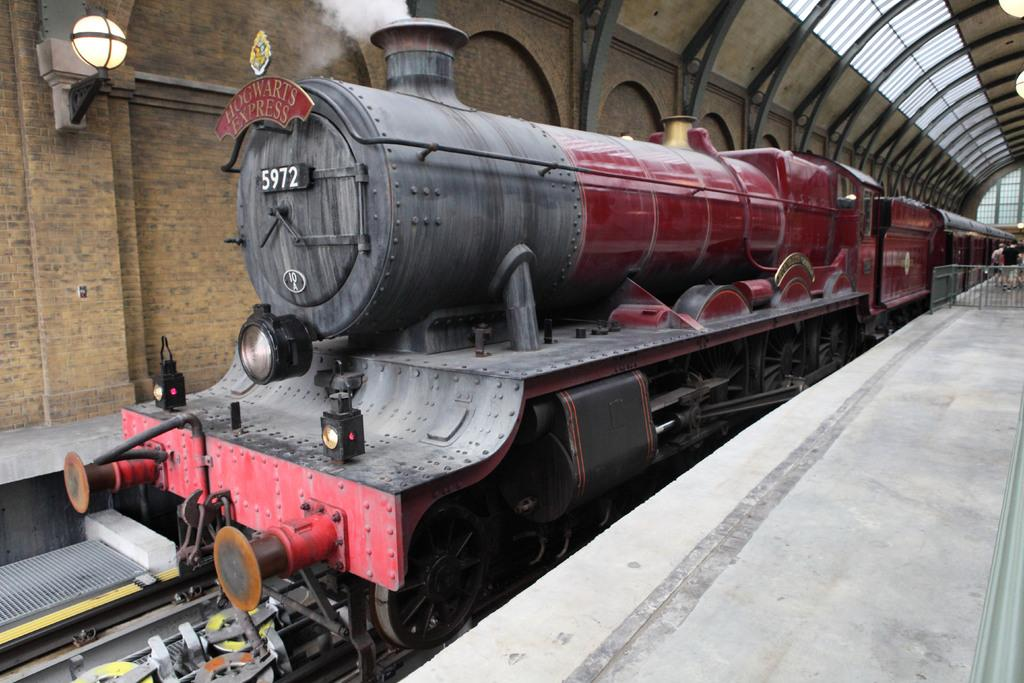What is the main subject of the image? The main subject of the image is a train. What can be seen written on the train? There is text written on the train. What type of lighting is visible on the train? There are lights visible on the train. What material is the roof of the train made of? The train has a metal roof. What is the result of the train's operation in the image? Exhaust fumes are present around the train. What type of barrier is present in the image? There is an iron fence in the image. Are there any people visible in the image? Yes, there are people in the image. What type of song is being sung by the brothers in the image? There are no brothers or song present in the image; it features a train and people. How many cars are parked next to the train in the image? There is no mention of cars in the image; it only features a train, an iron fence, and people. 